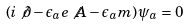Convert formula to latex. <formula><loc_0><loc_0><loc_500><loc_500>\left ( i \not { \partial } - \epsilon _ { a } e \not { A } - \epsilon _ { a } m \right ) \psi _ { a } = 0</formula> 